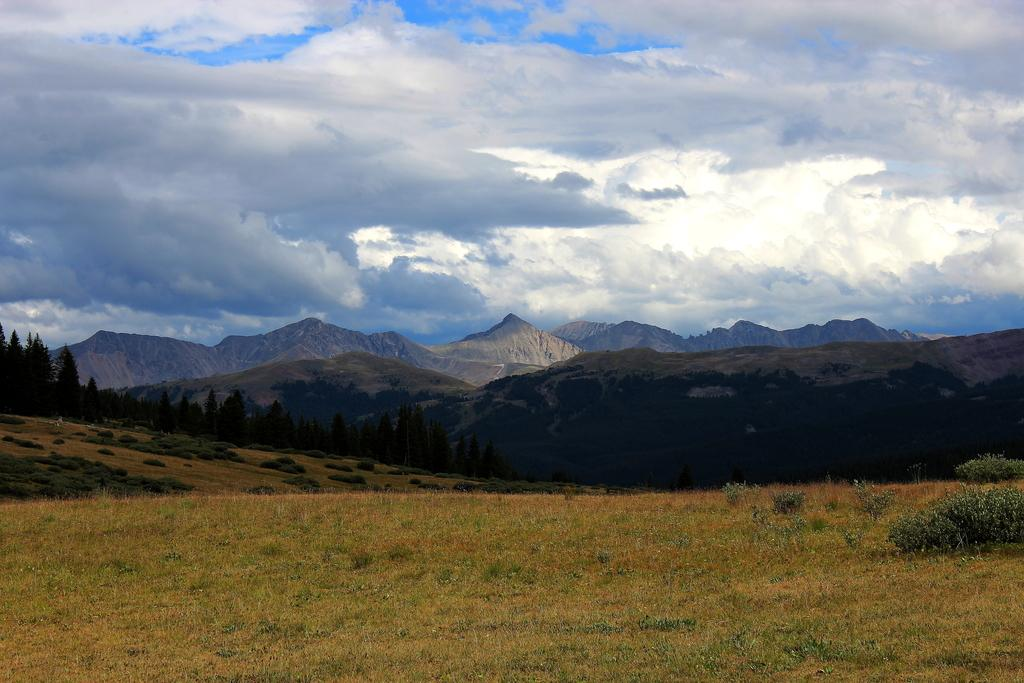What type of vegetation can be seen in the image? There are plants and many trees in the image. What natural features are visible in the background of the image? There are mountains and clouds visible in the background of the image. What part of the sky is visible in the image? The sky is visible in the background of the image. What type of worm can be seen crawling on the leaves in the image? There are no worms present in the image; it only features plants, trees, mountains, clouds, and the sky. 